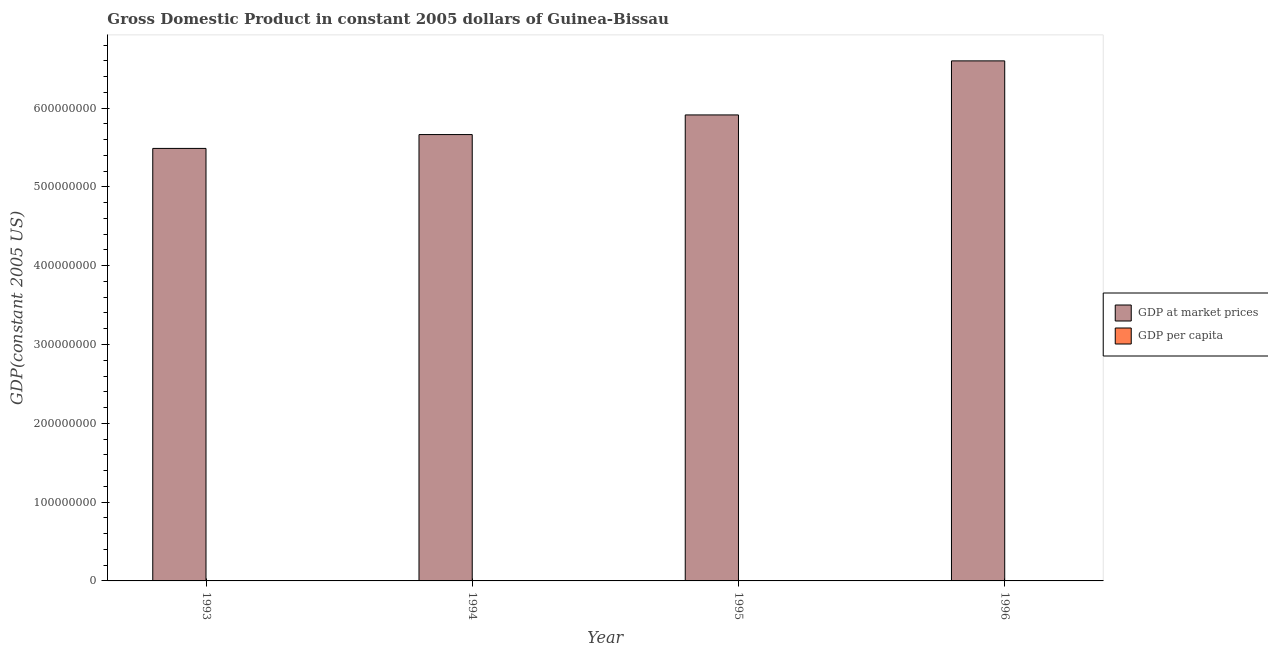How many groups of bars are there?
Provide a short and direct response. 4. Are the number of bars on each tick of the X-axis equal?
Keep it short and to the point. Yes. How many bars are there on the 1st tick from the left?
Give a very brief answer. 2. How many bars are there on the 1st tick from the right?
Offer a very short reply. 2. What is the gdp at market prices in 1996?
Offer a terse response. 6.60e+08. Across all years, what is the maximum gdp at market prices?
Keep it short and to the point. 6.60e+08. Across all years, what is the minimum gdp per capita?
Your response must be concise. 485.82. In which year was the gdp at market prices maximum?
Keep it short and to the point. 1996. What is the total gdp at market prices in the graph?
Your response must be concise. 2.37e+09. What is the difference between the gdp at market prices in 1993 and that in 1994?
Your answer should be compact. -1.76e+07. What is the difference between the gdp per capita in 1996 and the gdp at market prices in 1993?
Your response must be concise. 60.91. What is the average gdp per capita per year?
Your answer should be compact. 505.91. In how many years, is the gdp at market prices greater than 320000000 US$?
Provide a succinct answer. 4. What is the ratio of the gdp at market prices in 1993 to that in 1994?
Your response must be concise. 0.97. Is the gdp per capita in 1994 less than that in 1996?
Your response must be concise. Yes. What is the difference between the highest and the second highest gdp at market prices?
Your answer should be compact. 6.86e+07. What is the difference between the highest and the lowest gdp at market prices?
Provide a succinct answer. 1.11e+08. What does the 2nd bar from the left in 1996 represents?
Your response must be concise. GDP per capita. What does the 2nd bar from the right in 1993 represents?
Keep it short and to the point. GDP at market prices. How many years are there in the graph?
Ensure brevity in your answer.  4. What is the difference between two consecutive major ticks on the Y-axis?
Provide a succinct answer. 1.00e+08. Does the graph contain grids?
Make the answer very short. No. Where does the legend appear in the graph?
Give a very brief answer. Center right. How are the legend labels stacked?
Make the answer very short. Vertical. What is the title of the graph?
Offer a terse response. Gross Domestic Product in constant 2005 dollars of Guinea-Bissau. What is the label or title of the Y-axis?
Provide a short and direct response. GDP(constant 2005 US). What is the GDP(constant 2005 US) of GDP at market prices in 1993?
Offer a terse response. 5.49e+08. What is the GDP(constant 2005 US) of GDP per capita in 1993?
Your answer should be very brief. 485.82. What is the GDP(constant 2005 US) in GDP at market prices in 1994?
Offer a very short reply. 5.66e+08. What is the GDP(constant 2005 US) in GDP per capita in 1994?
Keep it short and to the point. 490.34. What is the GDP(constant 2005 US) in GDP at market prices in 1995?
Make the answer very short. 5.91e+08. What is the GDP(constant 2005 US) of GDP per capita in 1995?
Your answer should be very brief. 500.75. What is the GDP(constant 2005 US) in GDP at market prices in 1996?
Your response must be concise. 6.60e+08. What is the GDP(constant 2005 US) of GDP per capita in 1996?
Provide a short and direct response. 546.73. Across all years, what is the maximum GDP(constant 2005 US) of GDP at market prices?
Your answer should be compact. 6.60e+08. Across all years, what is the maximum GDP(constant 2005 US) of GDP per capita?
Keep it short and to the point. 546.73. Across all years, what is the minimum GDP(constant 2005 US) of GDP at market prices?
Offer a terse response. 5.49e+08. Across all years, what is the minimum GDP(constant 2005 US) in GDP per capita?
Your answer should be very brief. 485.82. What is the total GDP(constant 2005 US) of GDP at market prices in the graph?
Provide a succinct answer. 2.37e+09. What is the total GDP(constant 2005 US) in GDP per capita in the graph?
Offer a very short reply. 2023.64. What is the difference between the GDP(constant 2005 US) in GDP at market prices in 1993 and that in 1994?
Give a very brief answer. -1.76e+07. What is the difference between the GDP(constant 2005 US) of GDP per capita in 1993 and that in 1994?
Make the answer very short. -4.52. What is the difference between the GDP(constant 2005 US) of GDP at market prices in 1993 and that in 1995?
Give a very brief answer. -4.25e+07. What is the difference between the GDP(constant 2005 US) of GDP per capita in 1993 and that in 1995?
Make the answer very short. -14.92. What is the difference between the GDP(constant 2005 US) in GDP at market prices in 1993 and that in 1996?
Offer a very short reply. -1.11e+08. What is the difference between the GDP(constant 2005 US) of GDP per capita in 1993 and that in 1996?
Keep it short and to the point. -60.91. What is the difference between the GDP(constant 2005 US) of GDP at market prices in 1994 and that in 1995?
Keep it short and to the point. -2.49e+07. What is the difference between the GDP(constant 2005 US) of GDP per capita in 1994 and that in 1995?
Your answer should be compact. -10.41. What is the difference between the GDP(constant 2005 US) in GDP at market prices in 1994 and that in 1996?
Offer a terse response. -9.35e+07. What is the difference between the GDP(constant 2005 US) in GDP per capita in 1994 and that in 1996?
Your response must be concise. -56.39. What is the difference between the GDP(constant 2005 US) of GDP at market prices in 1995 and that in 1996?
Make the answer very short. -6.86e+07. What is the difference between the GDP(constant 2005 US) in GDP per capita in 1995 and that in 1996?
Offer a terse response. -45.99. What is the difference between the GDP(constant 2005 US) of GDP at market prices in 1993 and the GDP(constant 2005 US) of GDP per capita in 1994?
Keep it short and to the point. 5.49e+08. What is the difference between the GDP(constant 2005 US) in GDP at market prices in 1993 and the GDP(constant 2005 US) in GDP per capita in 1995?
Offer a terse response. 5.49e+08. What is the difference between the GDP(constant 2005 US) of GDP at market prices in 1993 and the GDP(constant 2005 US) of GDP per capita in 1996?
Keep it short and to the point. 5.49e+08. What is the difference between the GDP(constant 2005 US) in GDP at market prices in 1994 and the GDP(constant 2005 US) in GDP per capita in 1995?
Your response must be concise. 5.66e+08. What is the difference between the GDP(constant 2005 US) in GDP at market prices in 1994 and the GDP(constant 2005 US) in GDP per capita in 1996?
Ensure brevity in your answer.  5.66e+08. What is the difference between the GDP(constant 2005 US) of GDP at market prices in 1995 and the GDP(constant 2005 US) of GDP per capita in 1996?
Provide a short and direct response. 5.91e+08. What is the average GDP(constant 2005 US) of GDP at market prices per year?
Provide a succinct answer. 5.92e+08. What is the average GDP(constant 2005 US) of GDP per capita per year?
Provide a short and direct response. 505.91. In the year 1993, what is the difference between the GDP(constant 2005 US) in GDP at market prices and GDP(constant 2005 US) in GDP per capita?
Offer a terse response. 5.49e+08. In the year 1994, what is the difference between the GDP(constant 2005 US) in GDP at market prices and GDP(constant 2005 US) in GDP per capita?
Provide a short and direct response. 5.66e+08. In the year 1995, what is the difference between the GDP(constant 2005 US) of GDP at market prices and GDP(constant 2005 US) of GDP per capita?
Offer a very short reply. 5.91e+08. In the year 1996, what is the difference between the GDP(constant 2005 US) of GDP at market prices and GDP(constant 2005 US) of GDP per capita?
Offer a very short reply. 6.60e+08. What is the ratio of the GDP(constant 2005 US) in GDP per capita in 1993 to that in 1994?
Ensure brevity in your answer.  0.99. What is the ratio of the GDP(constant 2005 US) in GDP at market prices in 1993 to that in 1995?
Make the answer very short. 0.93. What is the ratio of the GDP(constant 2005 US) in GDP per capita in 1993 to that in 1995?
Offer a very short reply. 0.97. What is the ratio of the GDP(constant 2005 US) of GDP at market prices in 1993 to that in 1996?
Provide a succinct answer. 0.83. What is the ratio of the GDP(constant 2005 US) of GDP per capita in 1993 to that in 1996?
Your answer should be compact. 0.89. What is the ratio of the GDP(constant 2005 US) in GDP at market prices in 1994 to that in 1995?
Your answer should be very brief. 0.96. What is the ratio of the GDP(constant 2005 US) in GDP per capita in 1994 to that in 1995?
Your response must be concise. 0.98. What is the ratio of the GDP(constant 2005 US) in GDP at market prices in 1994 to that in 1996?
Offer a terse response. 0.86. What is the ratio of the GDP(constant 2005 US) of GDP per capita in 1994 to that in 1996?
Your answer should be compact. 0.9. What is the ratio of the GDP(constant 2005 US) of GDP at market prices in 1995 to that in 1996?
Offer a terse response. 0.9. What is the ratio of the GDP(constant 2005 US) of GDP per capita in 1995 to that in 1996?
Give a very brief answer. 0.92. What is the difference between the highest and the second highest GDP(constant 2005 US) of GDP at market prices?
Make the answer very short. 6.86e+07. What is the difference between the highest and the second highest GDP(constant 2005 US) in GDP per capita?
Give a very brief answer. 45.99. What is the difference between the highest and the lowest GDP(constant 2005 US) of GDP at market prices?
Keep it short and to the point. 1.11e+08. What is the difference between the highest and the lowest GDP(constant 2005 US) of GDP per capita?
Offer a terse response. 60.91. 